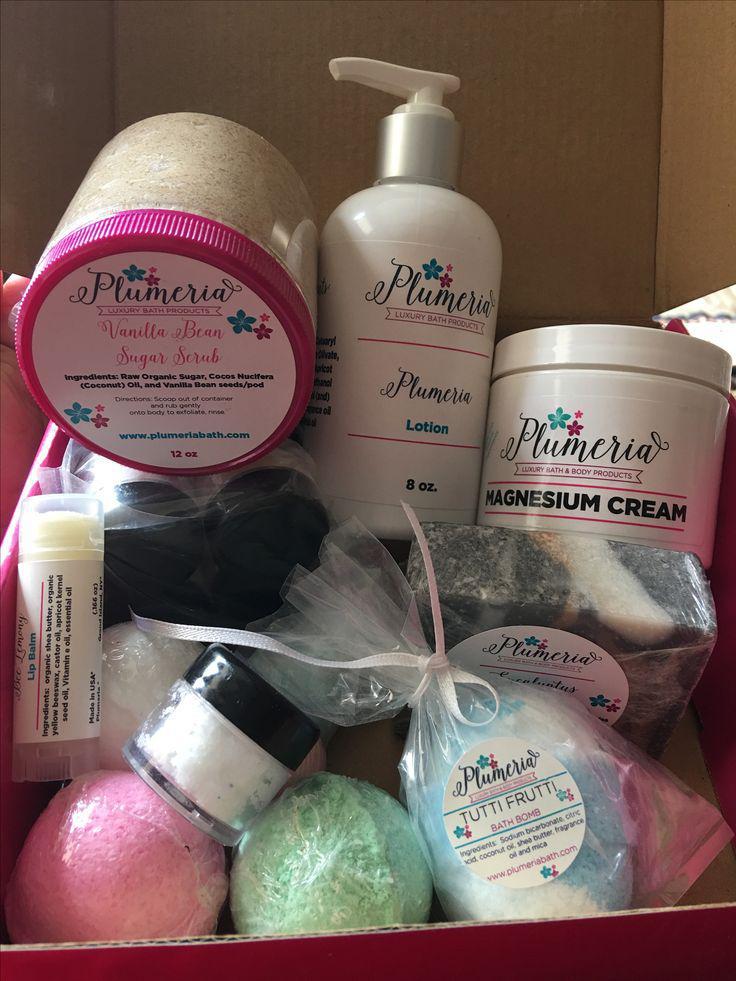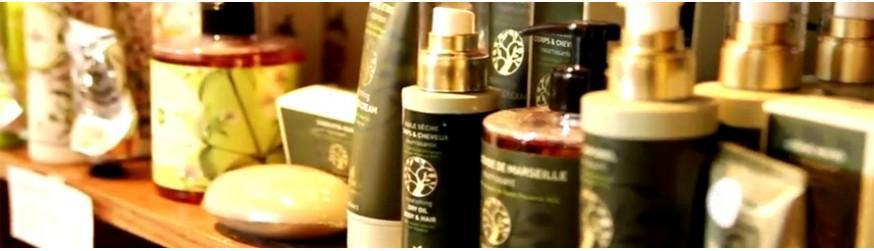The first image is the image on the left, the second image is the image on the right. For the images displayed, is the sentence "One image shows a variety of skincare products displayed upright on a table, and the other image shows a variety of skincare products, all of them in a container with sides." factually correct? Answer yes or no. Yes. 